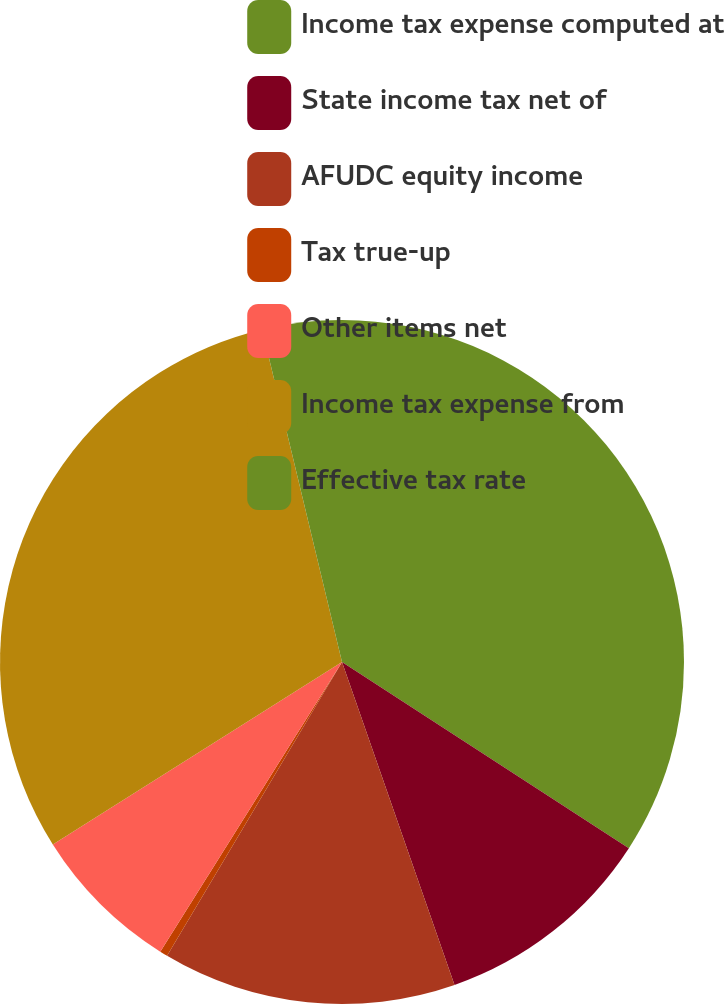Convert chart. <chart><loc_0><loc_0><loc_500><loc_500><pie_chart><fcel>Income tax expense computed at<fcel>State income tax net of<fcel>AFUDC equity income<fcel>Tax true-up<fcel>Other items net<fcel>Income tax expense from<fcel>Effective tax rate<nl><fcel>34.16%<fcel>10.5%<fcel>13.88%<fcel>0.37%<fcel>7.12%<fcel>30.21%<fcel>3.75%<nl></chart> 